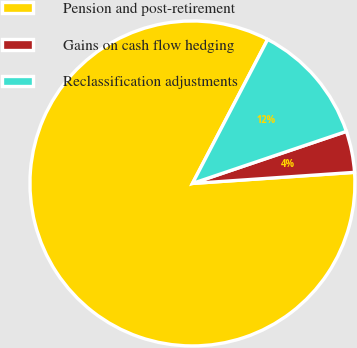Convert chart. <chart><loc_0><loc_0><loc_500><loc_500><pie_chart><fcel>Pension and post-retirement<fcel>Gains on cash flow hedging<fcel>Reclassification adjustments<nl><fcel>83.75%<fcel>4.1%<fcel>12.15%<nl></chart> 